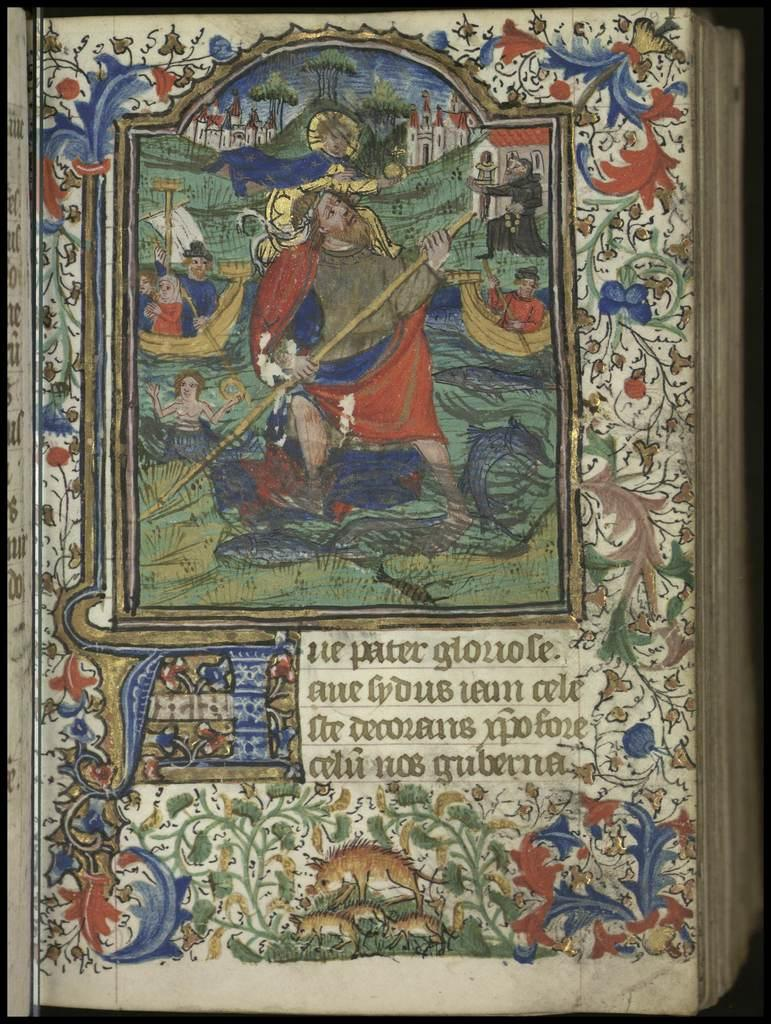<image>
Present a compact description of the photo's key features. A painted page in a book with latin written on it. 